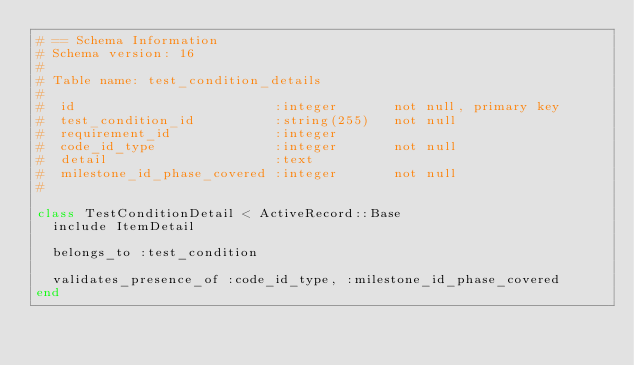<code> <loc_0><loc_0><loc_500><loc_500><_Ruby_># == Schema Information
# Schema version: 16
#
# Table name: test_condition_details
#
#  id                         :integer       not null, primary key
#  test_condition_id          :string(255)   not null
#  requirement_id             :integer       
#  code_id_type               :integer       not null
#  detail                     :text          
#  milestone_id_phase_covered :integer       not null
#

class TestConditionDetail < ActiveRecord::Base
  include ItemDetail

  belongs_to :test_condition
  
  validates_presence_of :code_id_type, :milestone_id_phase_covered
end
</code> 